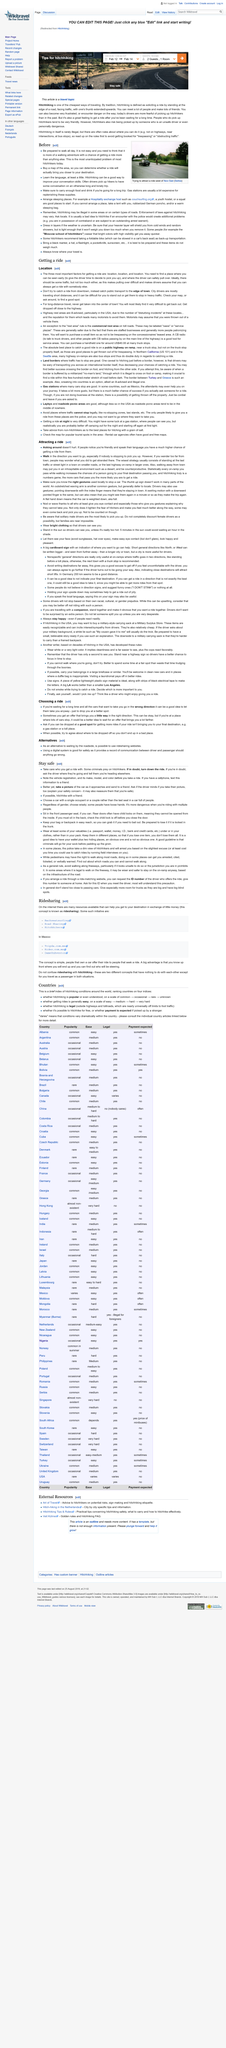Identify some key points in this picture. Hitchhiking can pose safety risks due to the possibility of being picked up by a driver who is an unsafe or personally dangerous individual. Hitchhiking can lead to two negative implications: potential legal issues and safety concerns. Hitchhiking alone can be dangerous, therefore, it is recommended to always hitchhike with a friend for safety. It is more likely that people will offer you a ride if you speak the same language as them. The three most critical elements for securing a ride are location, location, and location. 